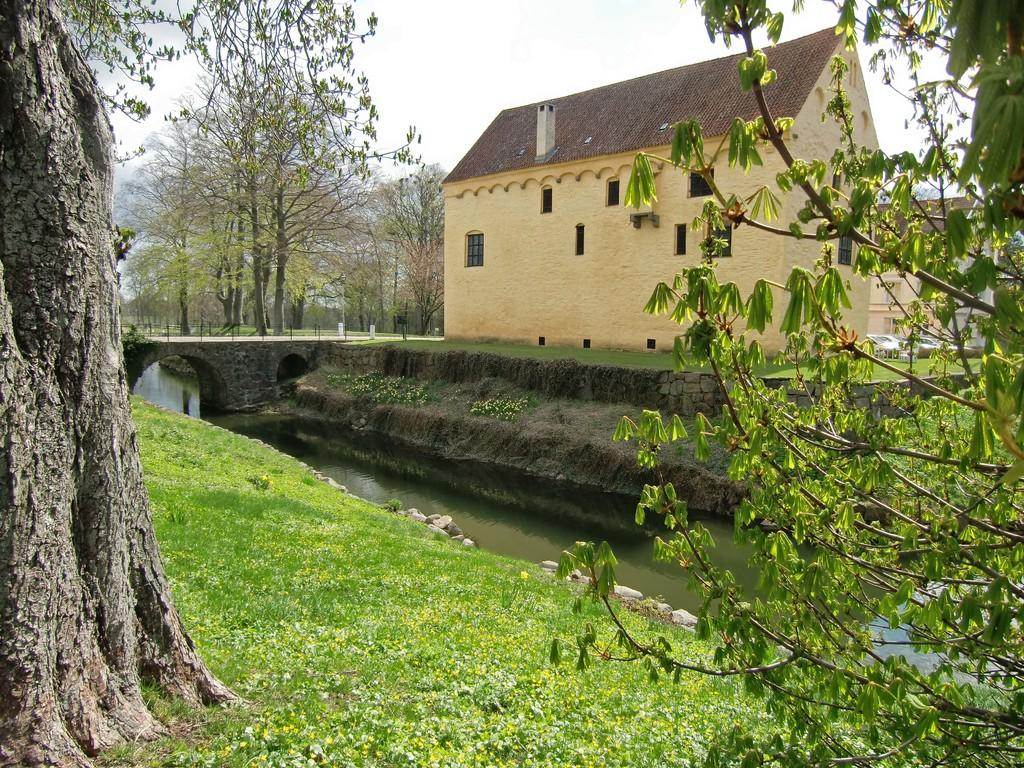What is visible in the center of the image? The sky is visible in the center of the image. What type of natural elements can be seen in the image? There are trees, water, and grass visible in the image. What type of man-made structures are present in the image? There are buildings and a bridge with pillars and arches in the image. Can you describe the unspecified objects in the image? Unfortunately, the provided facts do not specify the nature of these objects, so we cannot describe them. What type of comb is being used to style the trees in the image? There is no comb present in the image, and the trees are not being styled. 